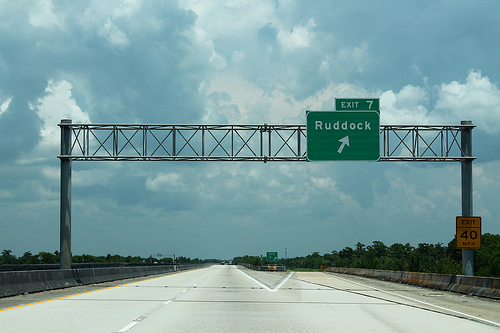<image>
Is there a sign in front of the road? Yes. The sign is positioned in front of the road, appearing closer to the camera viewpoint. 